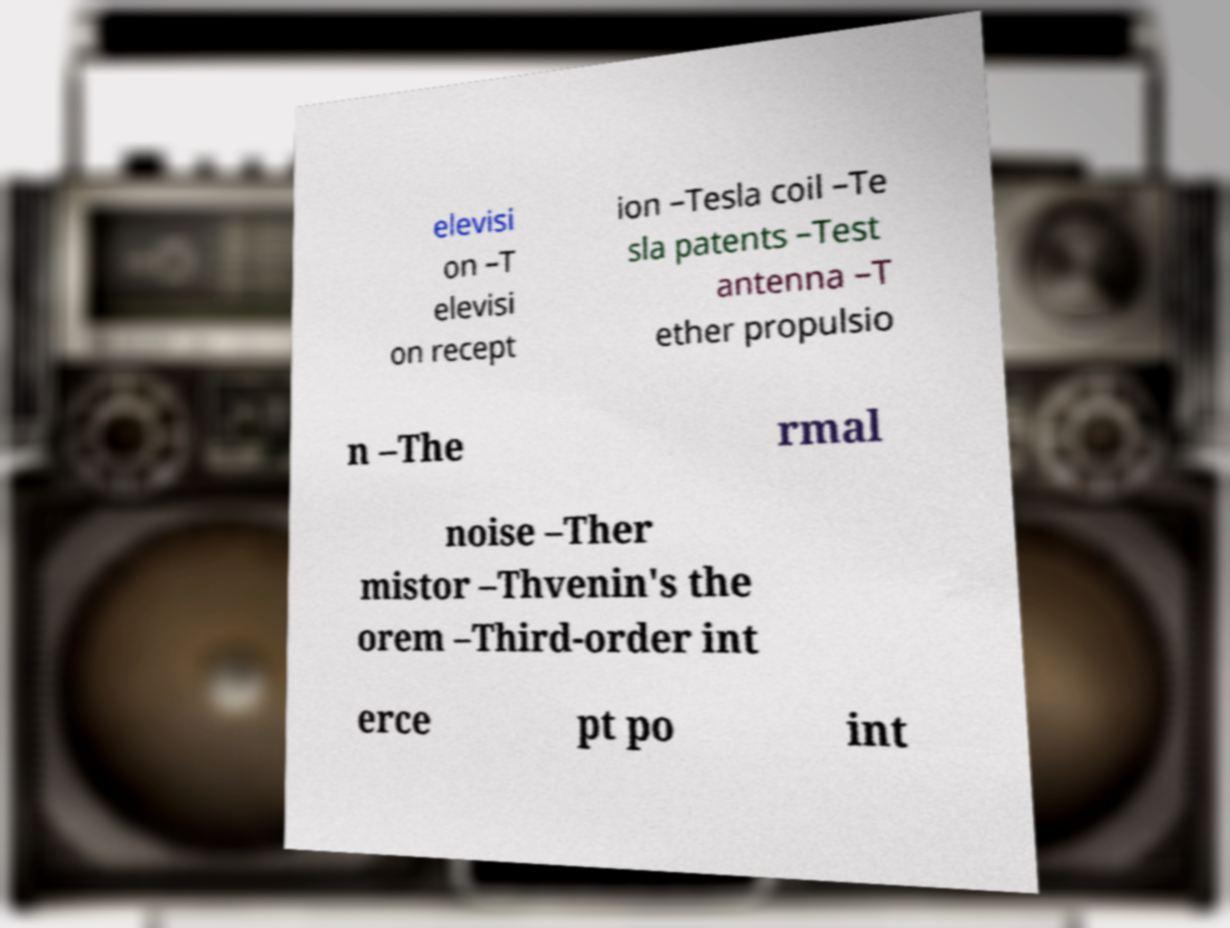For documentation purposes, I need the text within this image transcribed. Could you provide that? elevisi on –T elevisi on recept ion –Tesla coil –Te sla patents –Test antenna –T ether propulsio n –The rmal noise –Ther mistor –Thvenin's the orem –Third-order int erce pt po int 